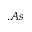<formula> <loc_0><loc_0><loc_500><loc_500>. A s</formula> 